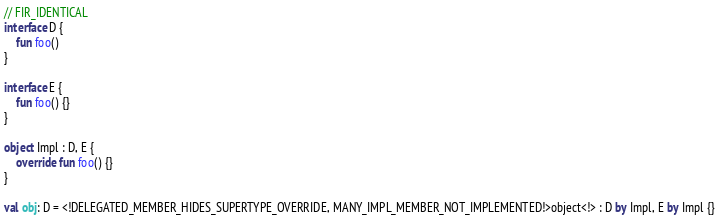Convert code to text. <code><loc_0><loc_0><loc_500><loc_500><_Kotlin_>// FIR_IDENTICAL
interface D {
    fun foo()
}

interface E {
    fun foo() {}
}

object Impl : D, E {
    override fun foo() {}
}

val obj: D = <!DELEGATED_MEMBER_HIDES_SUPERTYPE_OVERRIDE, MANY_IMPL_MEMBER_NOT_IMPLEMENTED!>object<!> : D by Impl, E by Impl {}</code> 